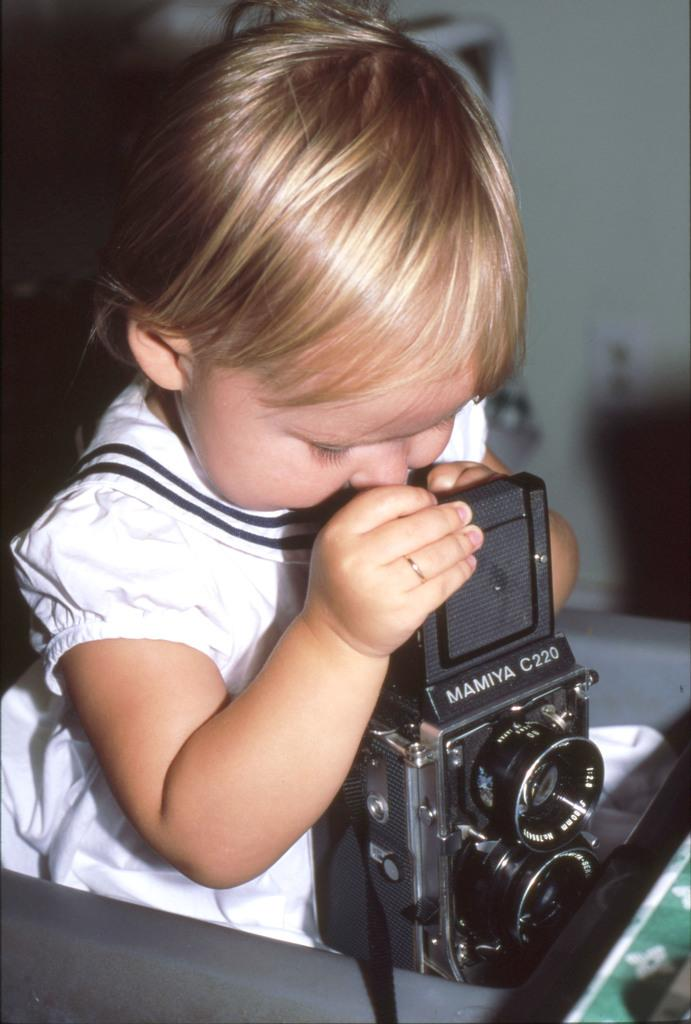What is the main subject of the image? The main subject of the image is a baby girl. Can you describe what the baby girl is wearing? The baby girl is wearing a frock. What is the baby girl holding in her hand? The baby girl is holding a camera in her hand. What type of transport is visible in the image? There is no transport visible in the image; it features a baby girl holding a camera. What kind of soup is being prepared in the image? There is no soup or any indication of food preparation in the image. 